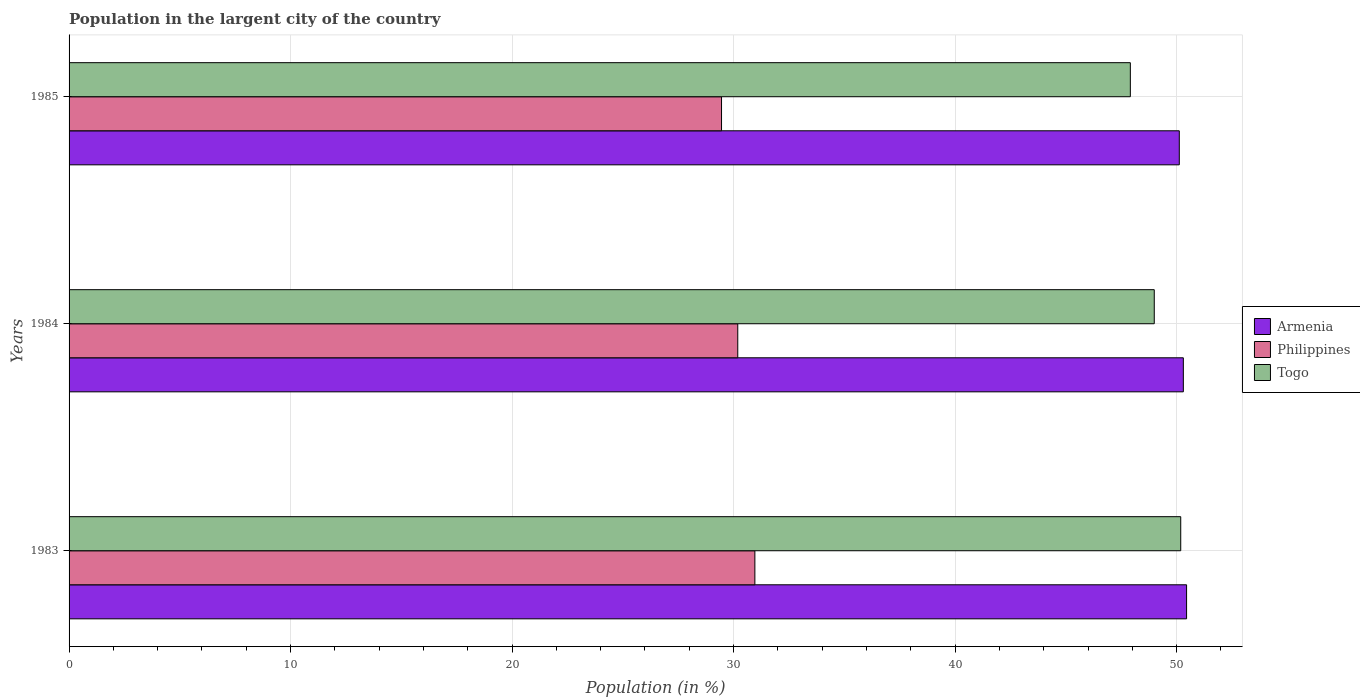How many groups of bars are there?
Your answer should be very brief. 3. What is the label of the 3rd group of bars from the top?
Make the answer very short. 1983. What is the percentage of population in the largent city in Togo in 1983?
Your answer should be compact. 50.19. Across all years, what is the maximum percentage of population in the largent city in Philippines?
Provide a short and direct response. 30.96. Across all years, what is the minimum percentage of population in the largent city in Armenia?
Offer a very short reply. 50.12. In which year was the percentage of population in the largent city in Armenia minimum?
Your answer should be very brief. 1985. What is the total percentage of population in the largent city in Philippines in the graph?
Keep it short and to the point. 90.61. What is the difference between the percentage of population in the largent city in Armenia in 1984 and that in 1985?
Offer a very short reply. 0.18. What is the difference between the percentage of population in the largent city in Armenia in 1985 and the percentage of population in the largent city in Togo in 1983?
Offer a terse response. -0.07. What is the average percentage of population in the largent city in Armenia per year?
Ensure brevity in your answer.  50.29. In the year 1983, what is the difference between the percentage of population in the largent city in Philippines and percentage of population in the largent city in Togo?
Give a very brief answer. -19.23. In how many years, is the percentage of population in the largent city in Armenia greater than 46 %?
Make the answer very short. 3. What is the ratio of the percentage of population in the largent city in Togo in 1984 to that in 1985?
Your answer should be very brief. 1.02. Is the percentage of population in the largent city in Philippines in 1983 less than that in 1984?
Offer a terse response. No. Is the difference between the percentage of population in the largent city in Philippines in 1983 and 1985 greater than the difference between the percentage of population in the largent city in Togo in 1983 and 1985?
Make the answer very short. No. What is the difference between the highest and the second highest percentage of population in the largent city in Togo?
Make the answer very short. 1.19. What is the difference between the highest and the lowest percentage of population in the largent city in Armenia?
Ensure brevity in your answer.  0.33. Is the sum of the percentage of population in the largent city in Armenia in 1983 and 1984 greater than the maximum percentage of population in the largent city in Togo across all years?
Offer a very short reply. Yes. What does the 3rd bar from the top in 1983 represents?
Keep it short and to the point. Armenia. What does the 1st bar from the bottom in 1984 represents?
Your response must be concise. Armenia. Is it the case that in every year, the sum of the percentage of population in the largent city in Armenia and percentage of population in the largent city in Togo is greater than the percentage of population in the largent city in Philippines?
Keep it short and to the point. Yes. How many bars are there?
Provide a short and direct response. 9. What is the difference between two consecutive major ticks on the X-axis?
Offer a very short reply. 10. What is the title of the graph?
Ensure brevity in your answer.  Population in the largent city of the country. Does "Burkina Faso" appear as one of the legend labels in the graph?
Your answer should be compact. No. What is the Population (in %) in Armenia in 1983?
Provide a succinct answer. 50.45. What is the Population (in %) of Philippines in 1983?
Give a very brief answer. 30.96. What is the Population (in %) in Togo in 1983?
Keep it short and to the point. 50.19. What is the Population (in %) in Armenia in 1984?
Keep it short and to the point. 50.3. What is the Population (in %) in Philippines in 1984?
Your answer should be very brief. 30.19. What is the Population (in %) of Togo in 1984?
Give a very brief answer. 48.99. What is the Population (in %) in Armenia in 1985?
Provide a succinct answer. 50.12. What is the Population (in %) in Philippines in 1985?
Ensure brevity in your answer.  29.46. What is the Population (in %) in Togo in 1985?
Your answer should be compact. 47.91. Across all years, what is the maximum Population (in %) of Armenia?
Ensure brevity in your answer.  50.45. Across all years, what is the maximum Population (in %) of Philippines?
Your answer should be compact. 30.96. Across all years, what is the maximum Population (in %) in Togo?
Offer a very short reply. 50.19. Across all years, what is the minimum Population (in %) of Armenia?
Your response must be concise. 50.12. Across all years, what is the minimum Population (in %) of Philippines?
Ensure brevity in your answer.  29.46. Across all years, what is the minimum Population (in %) in Togo?
Make the answer very short. 47.91. What is the total Population (in %) of Armenia in the graph?
Ensure brevity in your answer.  150.88. What is the total Population (in %) of Philippines in the graph?
Make the answer very short. 90.61. What is the total Population (in %) of Togo in the graph?
Make the answer very short. 147.09. What is the difference between the Population (in %) of Armenia in 1983 and that in 1984?
Provide a succinct answer. 0.15. What is the difference between the Population (in %) of Philippines in 1983 and that in 1984?
Your response must be concise. 0.77. What is the difference between the Population (in %) of Togo in 1983 and that in 1984?
Keep it short and to the point. 1.19. What is the difference between the Population (in %) in Armenia in 1983 and that in 1985?
Provide a short and direct response. 0.33. What is the difference between the Population (in %) in Philippines in 1983 and that in 1985?
Give a very brief answer. 1.51. What is the difference between the Population (in %) of Togo in 1983 and that in 1985?
Provide a short and direct response. 2.27. What is the difference between the Population (in %) of Armenia in 1984 and that in 1985?
Make the answer very short. 0.18. What is the difference between the Population (in %) in Philippines in 1984 and that in 1985?
Offer a very short reply. 0.73. What is the difference between the Population (in %) of Togo in 1984 and that in 1985?
Offer a very short reply. 1.08. What is the difference between the Population (in %) in Armenia in 1983 and the Population (in %) in Philippines in 1984?
Give a very brief answer. 20.26. What is the difference between the Population (in %) of Armenia in 1983 and the Population (in %) of Togo in 1984?
Your response must be concise. 1.46. What is the difference between the Population (in %) of Philippines in 1983 and the Population (in %) of Togo in 1984?
Give a very brief answer. -18.03. What is the difference between the Population (in %) in Armenia in 1983 and the Population (in %) in Philippines in 1985?
Offer a terse response. 20.99. What is the difference between the Population (in %) of Armenia in 1983 and the Population (in %) of Togo in 1985?
Provide a succinct answer. 2.54. What is the difference between the Population (in %) of Philippines in 1983 and the Population (in %) of Togo in 1985?
Your answer should be compact. -16.95. What is the difference between the Population (in %) in Armenia in 1984 and the Population (in %) in Philippines in 1985?
Offer a very short reply. 20.85. What is the difference between the Population (in %) of Armenia in 1984 and the Population (in %) of Togo in 1985?
Provide a succinct answer. 2.39. What is the difference between the Population (in %) in Philippines in 1984 and the Population (in %) in Togo in 1985?
Offer a terse response. -17.72. What is the average Population (in %) of Armenia per year?
Your answer should be very brief. 50.29. What is the average Population (in %) in Philippines per year?
Keep it short and to the point. 30.2. What is the average Population (in %) of Togo per year?
Make the answer very short. 49.03. In the year 1983, what is the difference between the Population (in %) of Armenia and Population (in %) of Philippines?
Ensure brevity in your answer.  19.49. In the year 1983, what is the difference between the Population (in %) of Armenia and Population (in %) of Togo?
Provide a short and direct response. 0.26. In the year 1983, what is the difference between the Population (in %) of Philippines and Population (in %) of Togo?
Your response must be concise. -19.23. In the year 1984, what is the difference between the Population (in %) of Armenia and Population (in %) of Philippines?
Ensure brevity in your answer.  20.12. In the year 1984, what is the difference between the Population (in %) of Armenia and Population (in %) of Togo?
Make the answer very short. 1.31. In the year 1984, what is the difference between the Population (in %) of Philippines and Population (in %) of Togo?
Offer a terse response. -18.8. In the year 1985, what is the difference between the Population (in %) of Armenia and Population (in %) of Philippines?
Offer a very short reply. 20.67. In the year 1985, what is the difference between the Population (in %) of Armenia and Population (in %) of Togo?
Provide a succinct answer. 2.21. In the year 1985, what is the difference between the Population (in %) of Philippines and Population (in %) of Togo?
Your response must be concise. -18.46. What is the ratio of the Population (in %) of Armenia in 1983 to that in 1984?
Provide a short and direct response. 1. What is the ratio of the Population (in %) in Philippines in 1983 to that in 1984?
Your answer should be very brief. 1.03. What is the ratio of the Population (in %) of Togo in 1983 to that in 1984?
Keep it short and to the point. 1.02. What is the ratio of the Population (in %) of Armenia in 1983 to that in 1985?
Make the answer very short. 1.01. What is the ratio of the Population (in %) in Philippines in 1983 to that in 1985?
Ensure brevity in your answer.  1.05. What is the ratio of the Population (in %) of Togo in 1983 to that in 1985?
Offer a terse response. 1.05. What is the ratio of the Population (in %) of Philippines in 1984 to that in 1985?
Your response must be concise. 1.02. What is the ratio of the Population (in %) in Togo in 1984 to that in 1985?
Offer a very short reply. 1.02. What is the difference between the highest and the second highest Population (in %) in Armenia?
Your response must be concise. 0.15. What is the difference between the highest and the second highest Population (in %) in Philippines?
Offer a terse response. 0.77. What is the difference between the highest and the second highest Population (in %) in Togo?
Provide a succinct answer. 1.19. What is the difference between the highest and the lowest Population (in %) of Armenia?
Make the answer very short. 0.33. What is the difference between the highest and the lowest Population (in %) in Philippines?
Provide a short and direct response. 1.51. What is the difference between the highest and the lowest Population (in %) in Togo?
Keep it short and to the point. 2.27. 